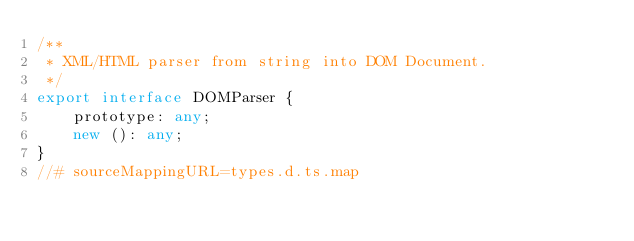<code> <loc_0><loc_0><loc_500><loc_500><_TypeScript_>/**
 * XML/HTML parser from string into DOM Document.
 */
export interface DOMParser {
    prototype: any;
    new (): any;
}
//# sourceMappingURL=types.d.ts.map</code> 